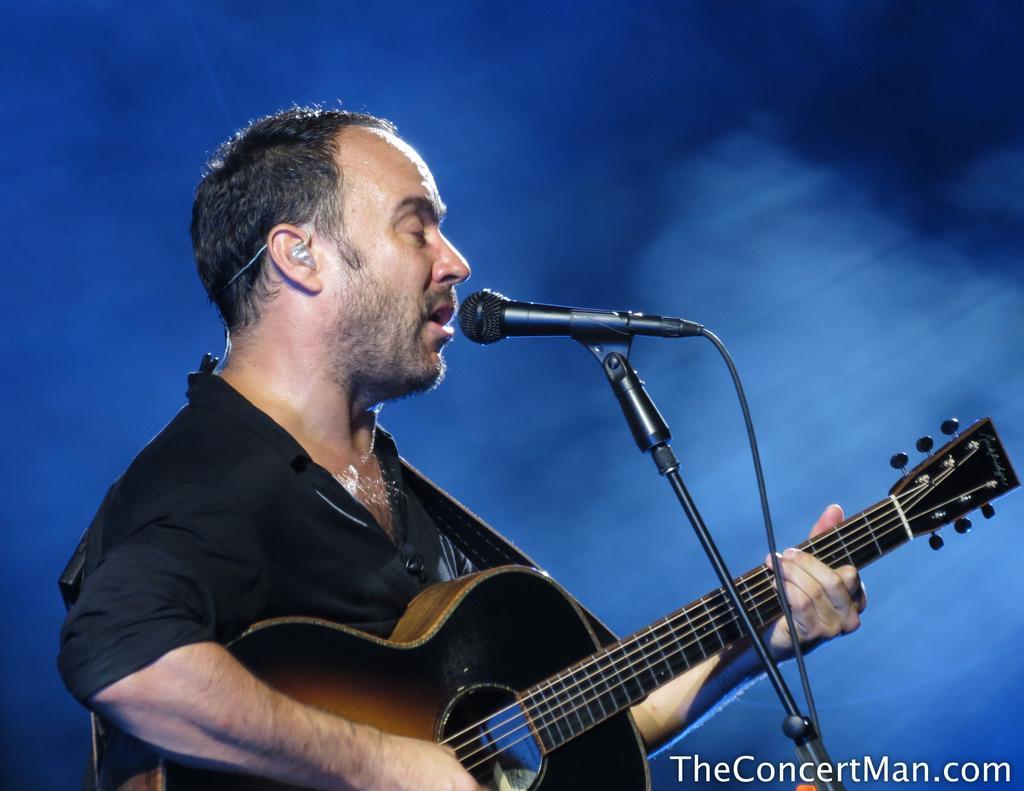How would you summarize this image in a sentence or two? This is a picture of a , man playing a guitar and singing the song in the microphone. 